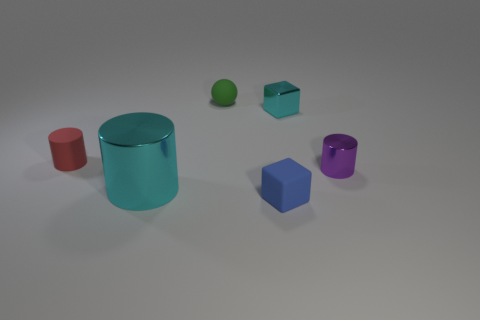There is a cube left of the small cube behind the matte object to the left of the tiny green thing; what color is it?
Offer a very short reply. Blue. There is a tiny shiny object in front of the small cyan block; is its color the same as the matte cylinder?
Provide a succinct answer. No. How many metal cylinders are in front of the tiny purple cylinder and behind the large cyan shiny cylinder?
Your answer should be very brief. 0. What size is the purple thing that is the same shape as the red thing?
Provide a succinct answer. Small. What number of tiny rubber cylinders are to the left of the small block to the right of the rubber object in front of the tiny purple object?
Offer a terse response. 1. What is the color of the big metallic cylinder in front of the tiny purple cylinder to the right of the tiny green matte ball?
Provide a short and direct response. Cyan. How many other objects are the same material as the cyan block?
Your answer should be very brief. 2. There is a small cylinder on the right side of the cyan metallic block; how many cylinders are behind it?
Offer a very short reply. 1. Is there anything else that has the same shape as the large cyan shiny object?
Offer a very short reply. Yes. Does the shiny cylinder that is on the right side of the shiny block have the same color as the sphere that is behind the red thing?
Your answer should be very brief. No. 